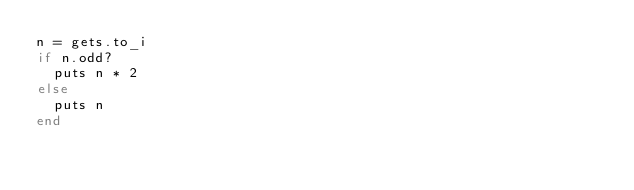<code> <loc_0><loc_0><loc_500><loc_500><_Ruby_>n = gets.to_i
if n.odd?
  puts n * 2
else
  puts n
end
</code> 